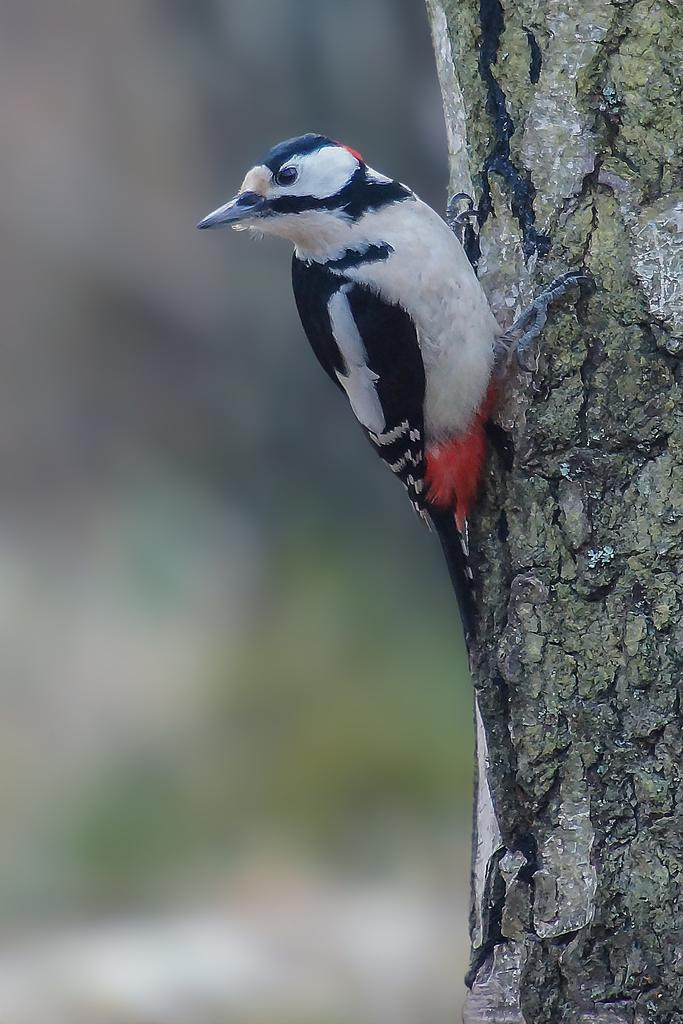What type of animal can be seen in the image? There is a bird in the image. Where is the bird located? The bird is standing on a tree trunk. Can you describe the background of the image? The background of the image is blurry. What type of fang does the stranger have in the image? There is no stranger or fang present in the image; it features a bird standing on a tree trunk with a blurry background. 